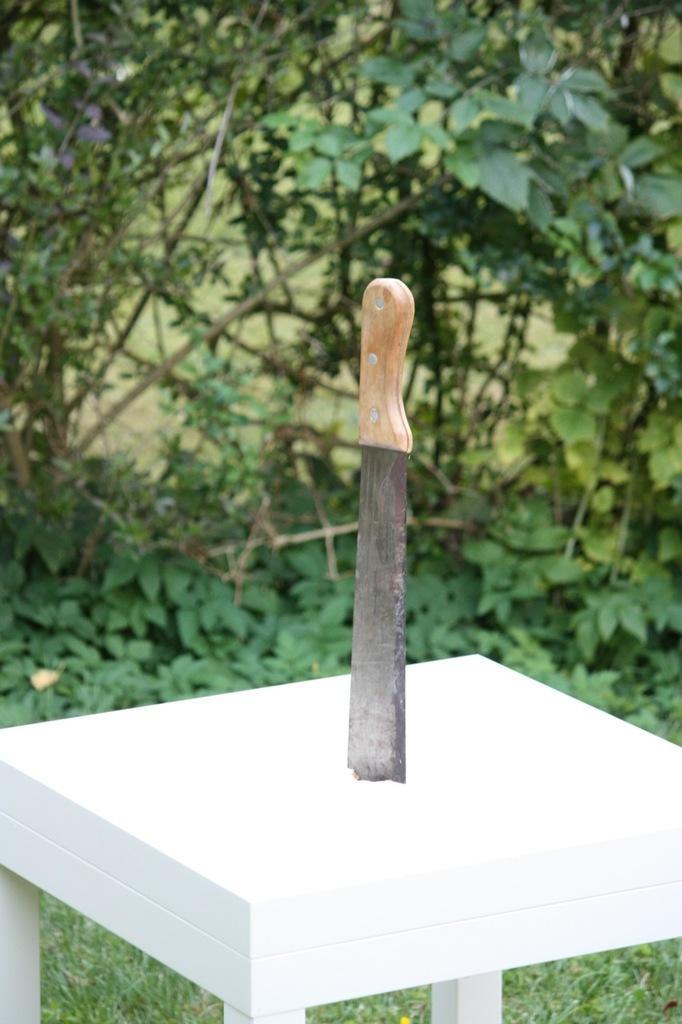In one or two sentences, can you explain what this image depicts? In the picture I can see a knife on a white color table. In the background I can see plants. The background of the image is blurred. 